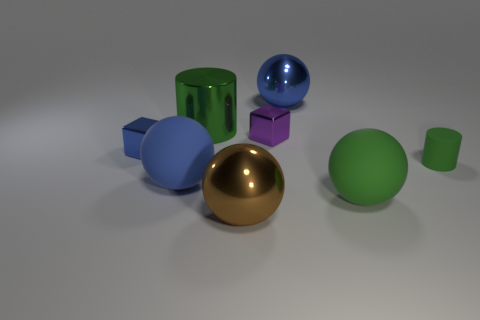What is the shape of the small purple metal object?
Ensure brevity in your answer.  Cube. Do the blue shiny ball and the brown metal thing have the same size?
Give a very brief answer. Yes. What number of other things are there of the same shape as the large brown shiny object?
Provide a succinct answer. 3. The tiny shiny thing to the right of the brown metal object has what shape?
Provide a succinct answer. Cube. There is a green rubber thing to the left of the small cylinder; is its shape the same as the large matte object that is on the left side of the big blue metallic thing?
Make the answer very short. Yes. Is the number of big blue spheres in front of the blue matte thing the same as the number of tiny green cylinders?
Provide a succinct answer. No. Is there any other thing that is the same size as the green shiny cylinder?
Keep it short and to the point. Yes. There is a green thing that is the same shape as the large brown object; what is its material?
Your answer should be compact. Rubber. The big green thing to the left of the green object that is in front of the blue matte ball is what shape?
Provide a succinct answer. Cylinder. Is the big sphere behind the tiny green matte thing made of the same material as the purple object?
Give a very brief answer. Yes. 